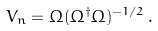Convert formula to latex. <formula><loc_0><loc_0><loc_500><loc_500>V _ { n } = \Omega ( \Omega ^ { \dagger } \Omega ) ^ { - 1 / 2 } \, .</formula> 